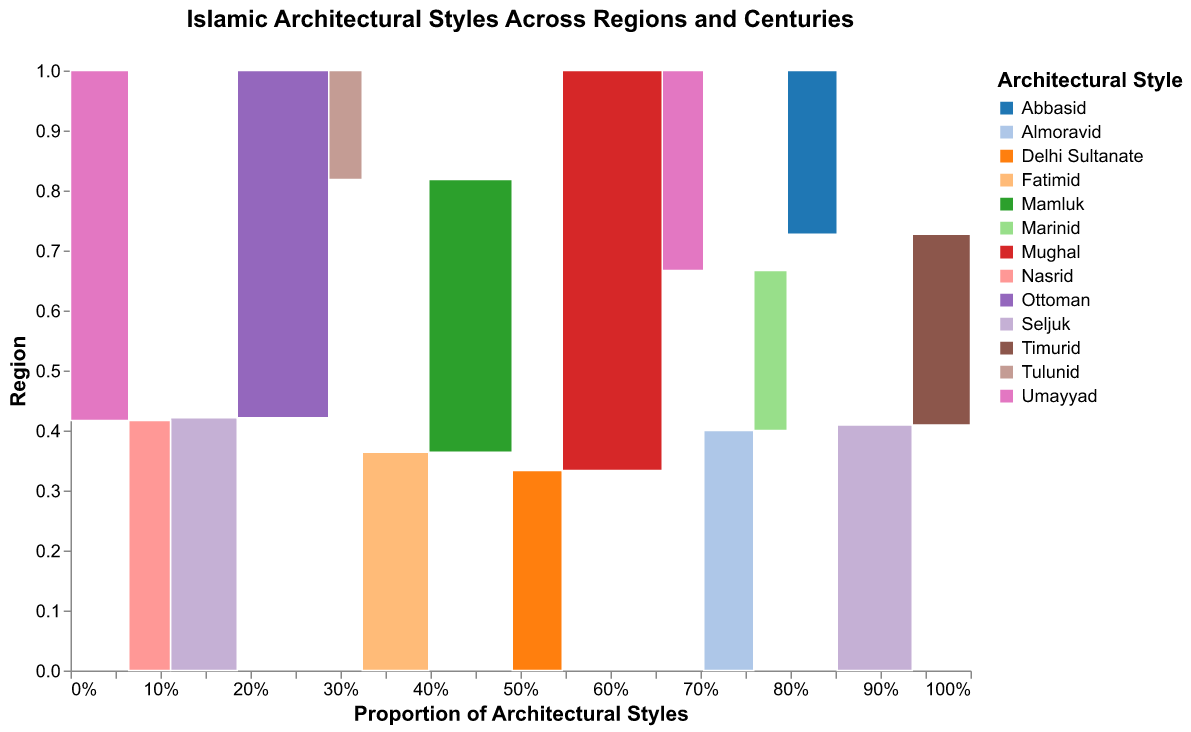What is the main title of the figure? The main title is typically located at the top center of the figure and visually denotes the theme of the plot.
Answer: Islamic Architectural Styles Across Regions and Centuries Which region has the highest proportion of the Ottoman architectural style? Look for the color representing Ottoman and compare the areas of the region blocks that contain this style. Anatolia has the largest section colored for Ottoman.
Answer: Anatolia How many different architectural styles are depicted for the Maghreb region? Identify the distinct colors within the Maghreb region's row that represent different architectural styles. The colors representing Umayyad, Almoravid, and Marinid show there are three styles.
Answer: 3 In which century does the Nasrid architectural style appear in Al-Andalus? Find the color representing Nasrid in the Al-Andalus row and check its corresponding century label.
Answer: 11th-13th Which region shows a significant diversity of architectural styles compared to others? Examine the number of different colors (architectural styles) in each region. Egypt and Persia have three distinct styles, but Persia spans more centuries prominently.
Answer: Persia Comparing Persia and India, which region has a greater count of architectural style entries in the 14th-16th century? Sum up the counts of architectural styles for both regions in the 14th-16th century (Persia: 35 Timurid, India: 60 Mughal). India has more entries.
Answer: India Is the presence of Seljuk architecture exclusive to one region or does it spread across multiple regions? Look for the color representing the Seljuk style across different regions' rows. Both Persia and Anatolia have Seljuk architecture.
Answer: Multiple regions Which two regions have the earliest Islamic architectural styles depicted? Identify the colors from earlier centuries (8th-10th) and correlate them with their respective regions (Persia - Abbasid, Maghreb - Umayyad, Al-Andalus - Umayyad, Egypt - Tulunid). Maghreb and Egypt have entries from the 8th-10th centuries.
Answer: Maghreb, Egypt Which architectural style has the highest count in the India region? Look at the counts associated with architectural styles within the India row. The Mughal style in the 14th-16th century has the highest count (60).
Answer: Mughal What are the three most prominent architectural styles in the 14th-16th centuries across all regions? Compare the blocks of architectural styles within this century range and sum up their counts across regions (Ottoman in Anatolia, Timurid in Persia, Mughal in India). Mughal is the most prominent.
Answer: Ottoman, Timurid, Mughal 